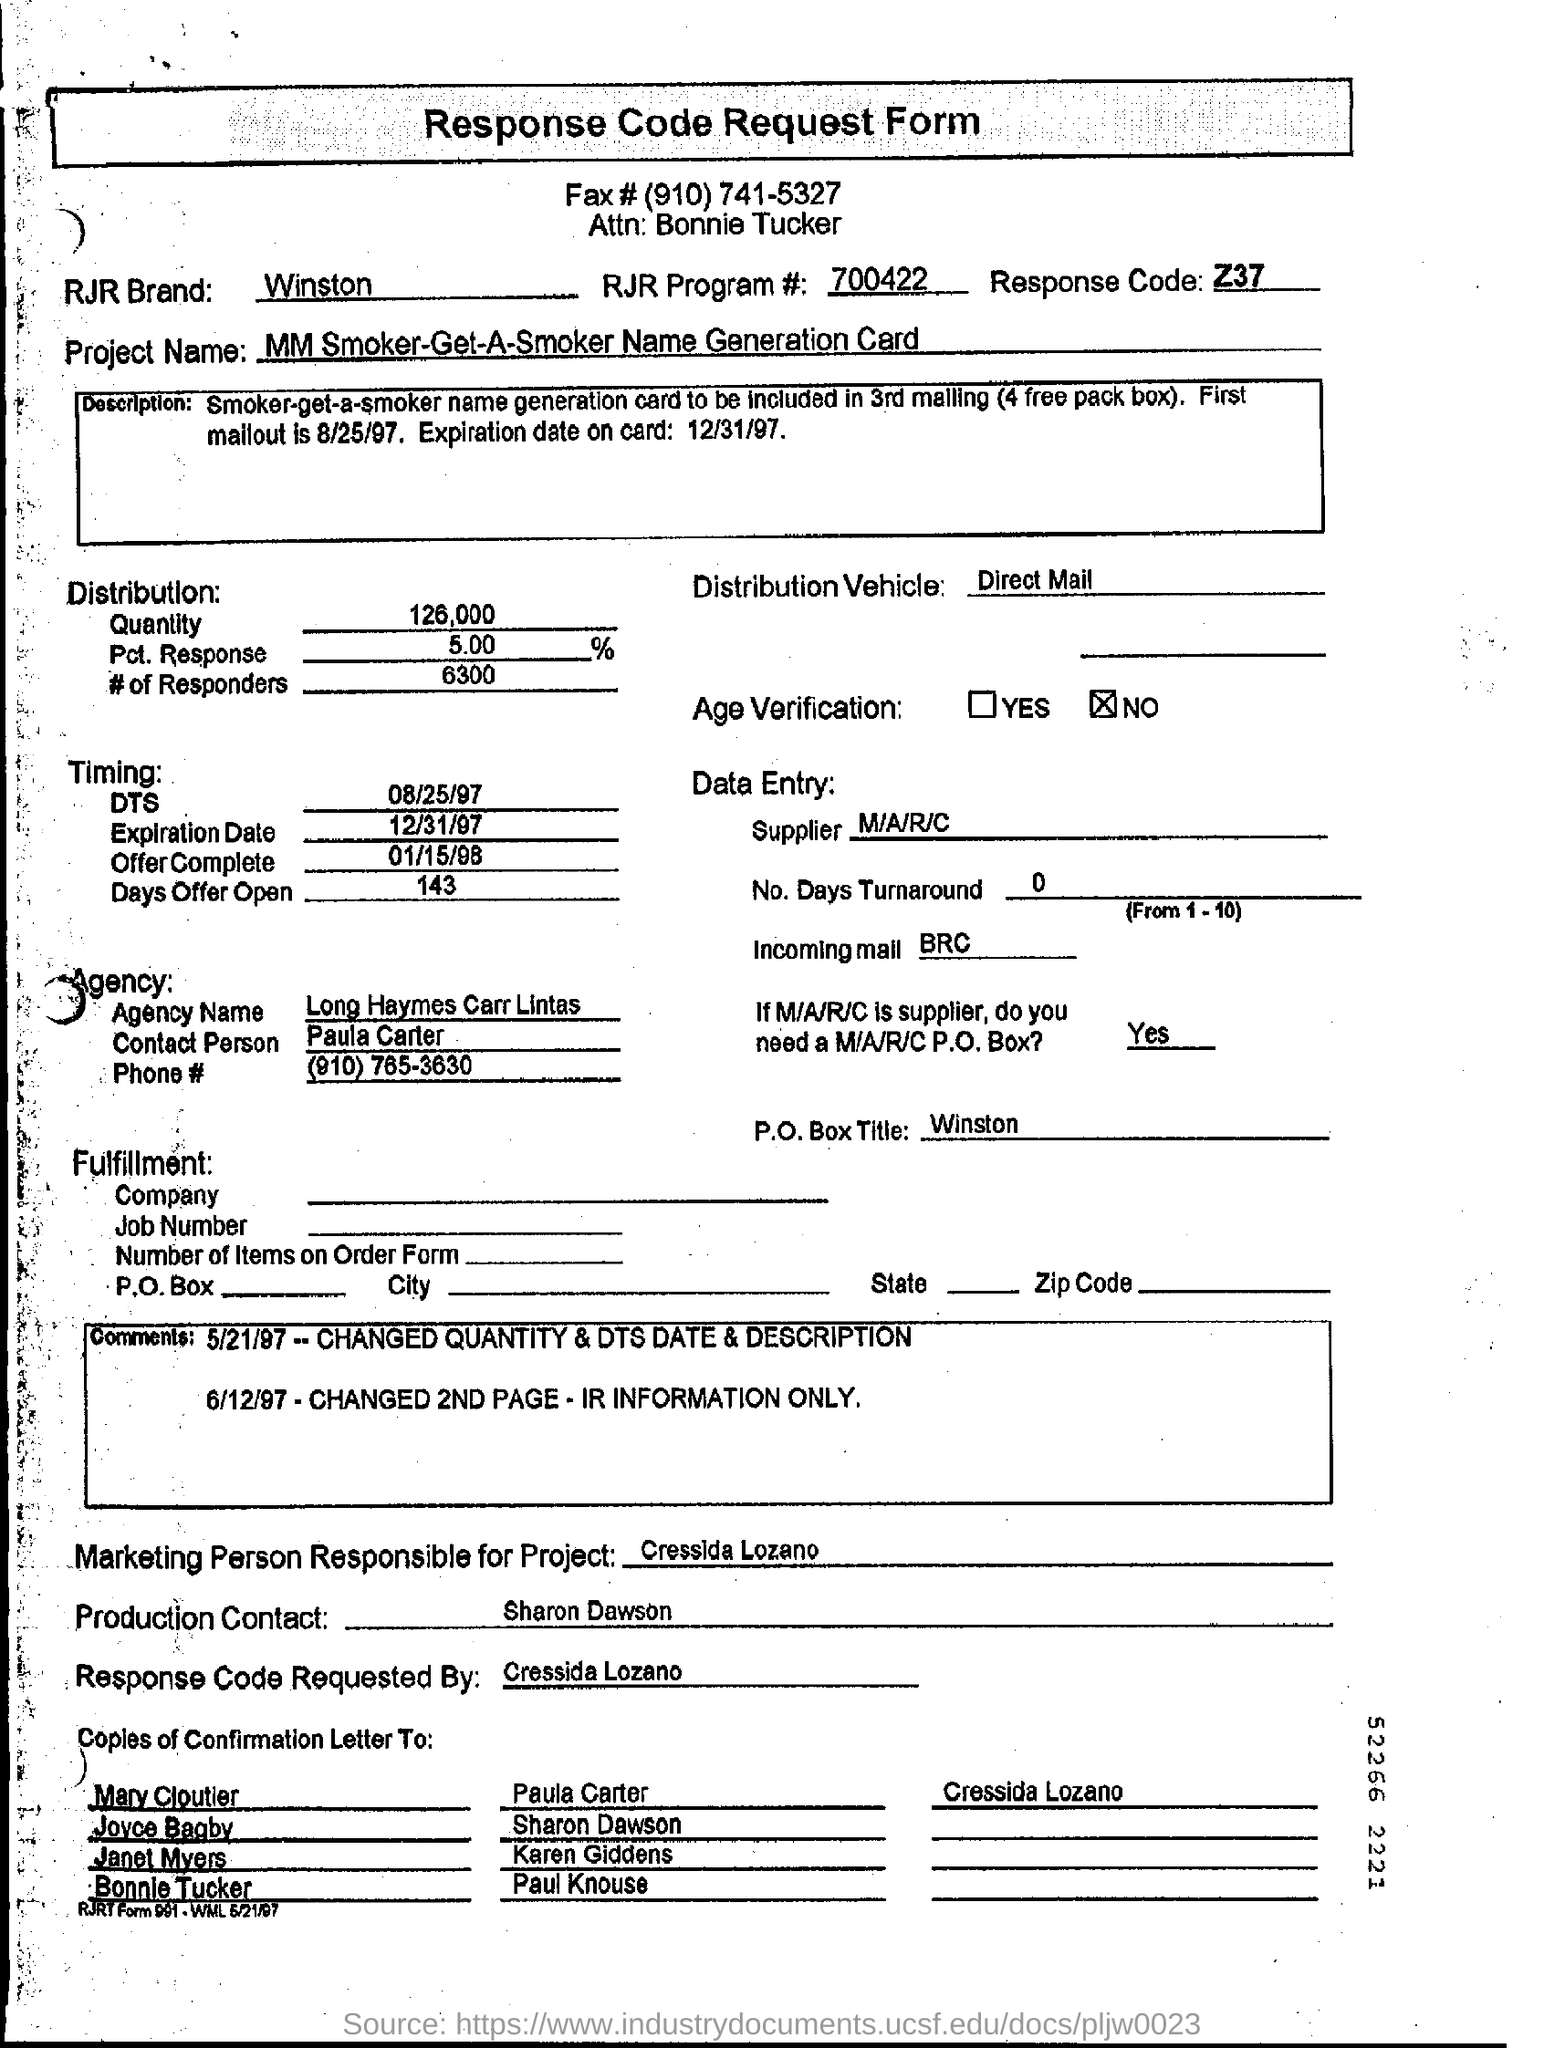Point out several critical features in this image. The RJR program number mentioned on the response code request form is 700422. The response code mentioned in the form is Z37.." can be expressed as "The Z37.. code is mentioned in the form as the response code. The RJR brand mentioned on the response code request form is Winston. The offer is open for 143 days. Cressida Lozano requested the response code for the request form. 